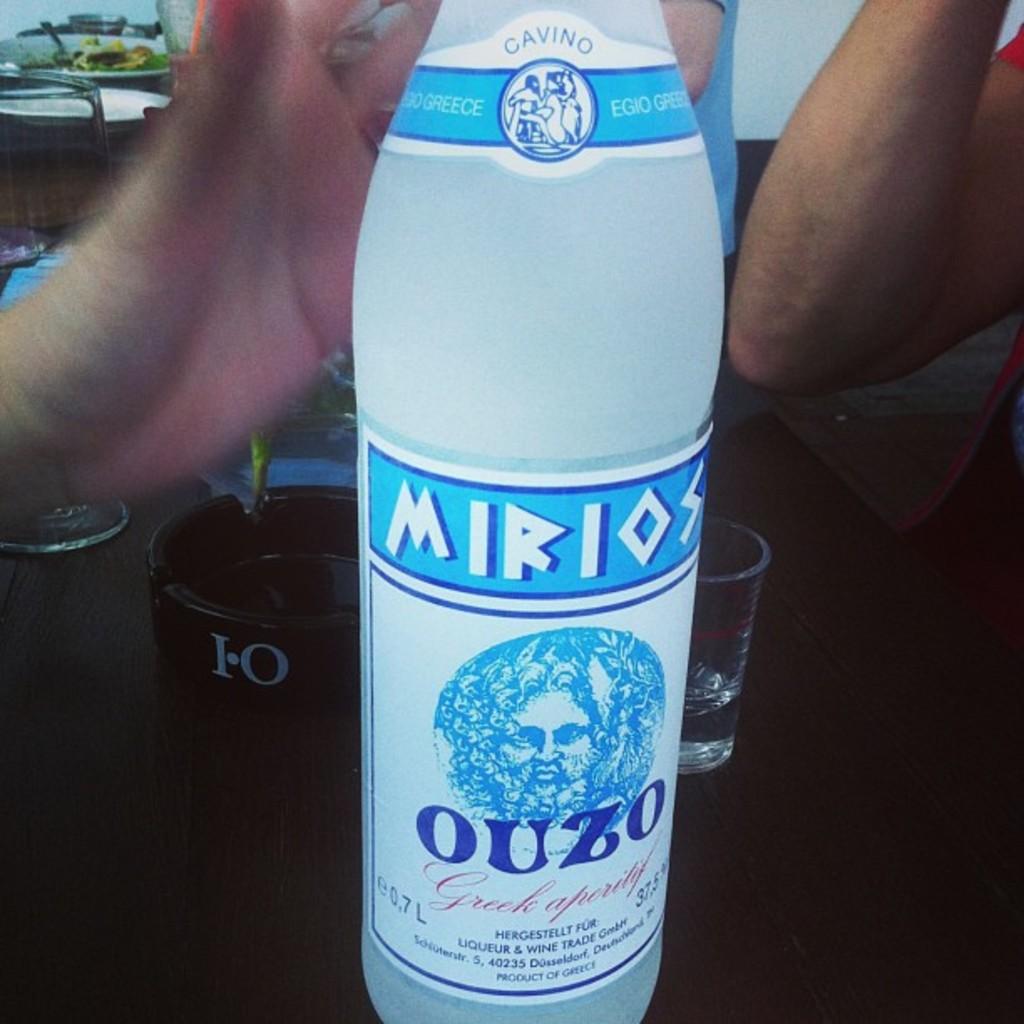Where is the drink from?
Provide a short and direct response. Greece. What drink is this?
Give a very brief answer. Ouzo. 